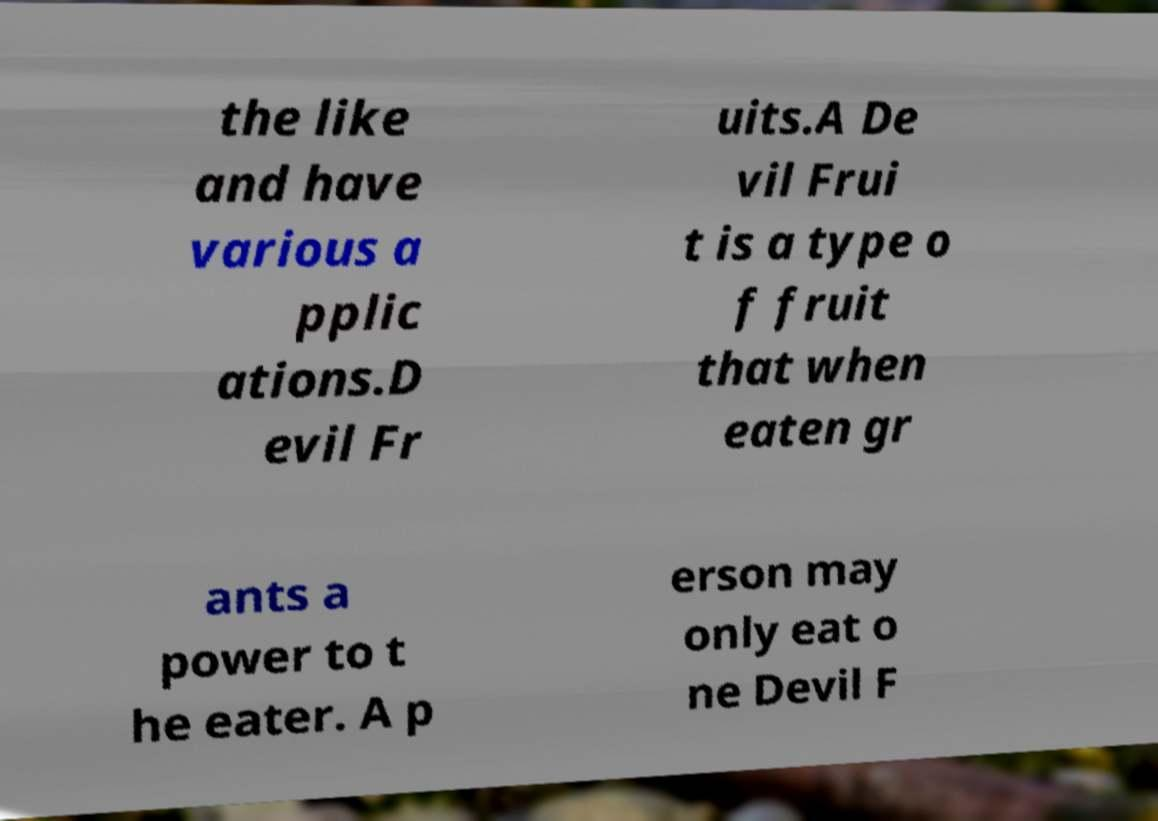I need the written content from this picture converted into text. Can you do that? the like and have various a pplic ations.D evil Fr uits.A De vil Frui t is a type o f fruit that when eaten gr ants a power to t he eater. A p erson may only eat o ne Devil F 